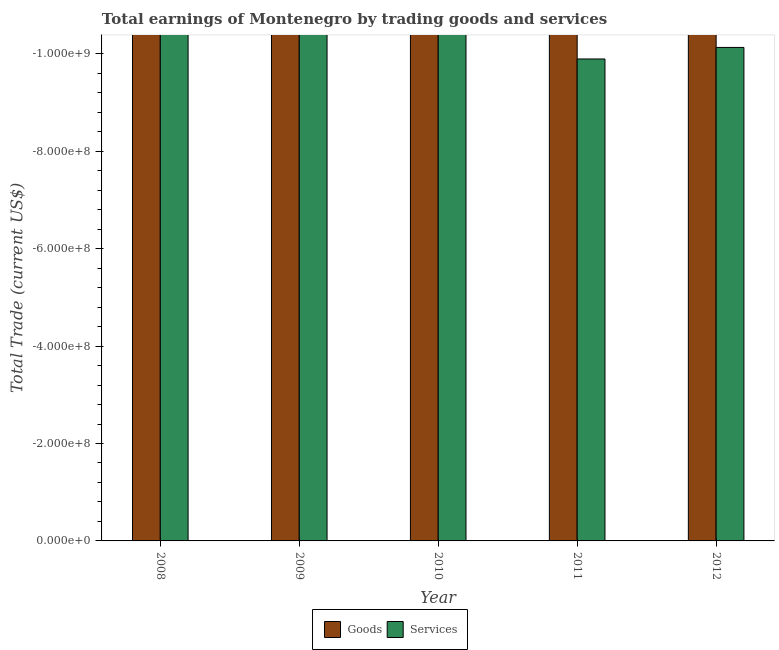Are the number of bars per tick equal to the number of legend labels?
Your response must be concise. No. What is the label of the 2nd group of bars from the left?
Offer a terse response. 2009. Across all years, what is the minimum amount earned by trading services?
Offer a terse response. 0. In how many years, is the amount earned by trading goods greater than -320000000 US$?
Keep it short and to the point. 0. In how many years, is the amount earned by trading goods greater than the average amount earned by trading goods taken over all years?
Offer a terse response. 0. Are all the bars in the graph horizontal?
Ensure brevity in your answer.  No. How many years are there in the graph?
Keep it short and to the point. 5. Does the graph contain any zero values?
Provide a short and direct response. Yes. Does the graph contain grids?
Your response must be concise. No. Where does the legend appear in the graph?
Ensure brevity in your answer.  Bottom center. How are the legend labels stacked?
Your answer should be compact. Horizontal. What is the title of the graph?
Make the answer very short. Total earnings of Montenegro by trading goods and services. Does "Non-resident workers" appear as one of the legend labels in the graph?
Offer a very short reply. No. What is the label or title of the X-axis?
Offer a very short reply. Year. What is the label or title of the Y-axis?
Your answer should be compact. Total Trade (current US$). What is the Total Trade (current US$) in Goods in 2009?
Offer a very short reply. 0. What is the Total Trade (current US$) in Services in 2012?
Give a very brief answer. 0. What is the total Total Trade (current US$) of Goods in the graph?
Provide a short and direct response. 0. What is the total Total Trade (current US$) in Services in the graph?
Your response must be concise. 0. What is the average Total Trade (current US$) of Goods per year?
Give a very brief answer. 0. 